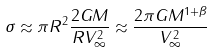Convert formula to latex. <formula><loc_0><loc_0><loc_500><loc_500>\sigma \approx \pi R ^ { 2 } \frac { 2 G M } { R V ^ { 2 } _ { \infty } } \approx \frac { 2 \pi G M ^ { 1 + \beta } } { V ^ { 2 } _ { \infty } }</formula> 